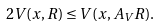<formula> <loc_0><loc_0><loc_500><loc_500>2 V ( x , R ) \leq V ( x , A _ { V } R ) .</formula> 